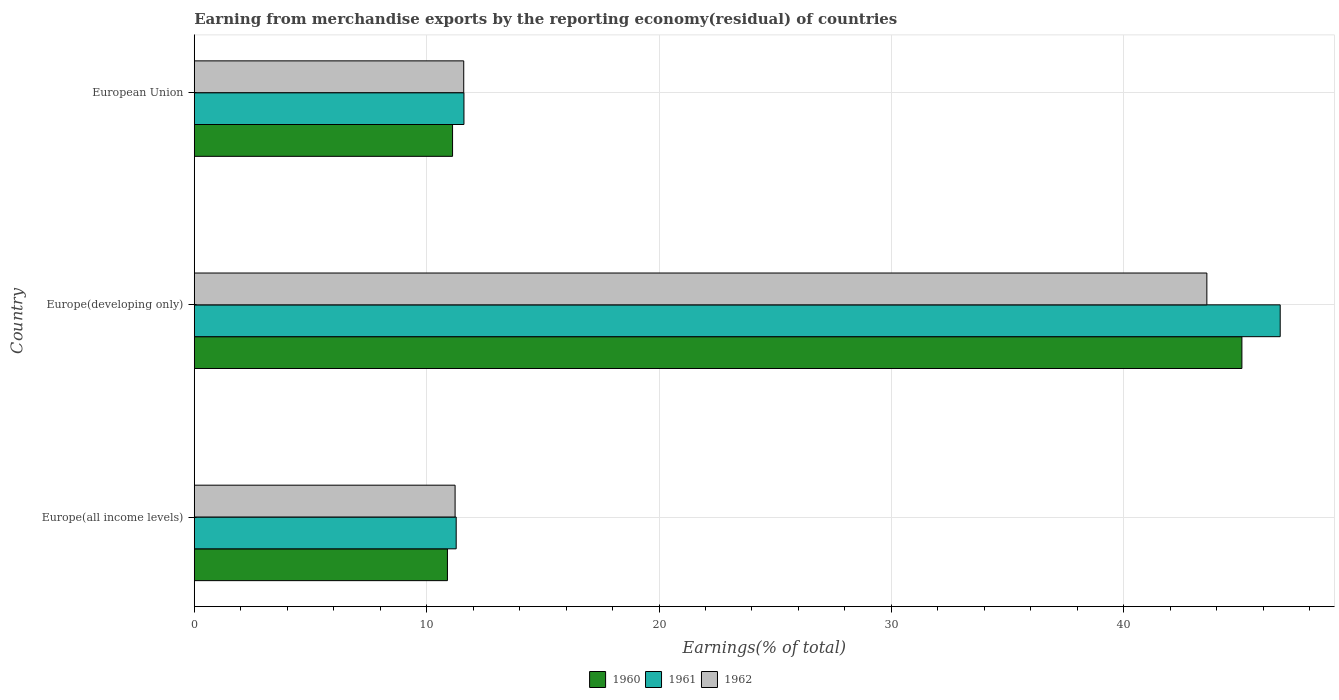Are the number of bars on each tick of the Y-axis equal?
Provide a succinct answer. Yes. How many bars are there on the 1st tick from the bottom?
Your response must be concise. 3. What is the label of the 3rd group of bars from the top?
Offer a terse response. Europe(all income levels). In how many cases, is the number of bars for a given country not equal to the number of legend labels?
Give a very brief answer. 0. What is the percentage of amount earned from merchandise exports in 1961 in European Union?
Ensure brevity in your answer.  11.61. Across all countries, what is the maximum percentage of amount earned from merchandise exports in 1962?
Your answer should be compact. 43.58. Across all countries, what is the minimum percentage of amount earned from merchandise exports in 1961?
Your answer should be very brief. 11.27. In which country was the percentage of amount earned from merchandise exports in 1962 maximum?
Keep it short and to the point. Europe(developing only). In which country was the percentage of amount earned from merchandise exports in 1962 minimum?
Keep it short and to the point. Europe(all income levels). What is the total percentage of amount earned from merchandise exports in 1962 in the graph?
Offer a very short reply. 66.4. What is the difference between the percentage of amount earned from merchandise exports in 1960 in Europe(developing only) and that in European Union?
Provide a short and direct response. 33.97. What is the difference between the percentage of amount earned from merchandise exports in 1961 in European Union and the percentage of amount earned from merchandise exports in 1962 in Europe(developing only)?
Provide a short and direct response. -31.97. What is the average percentage of amount earned from merchandise exports in 1962 per country?
Ensure brevity in your answer.  22.13. What is the difference between the percentage of amount earned from merchandise exports in 1960 and percentage of amount earned from merchandise exports in 1961 in Europe(all income levels)?
Offer a terse response. -0.38. In how many countries, is the percentage of amount earned from merchandise exports in 1962 greater than 10 %?
Your response must be concise. 3. What is the ratio of the percentage of amount earned from merchandise exports in 1962 in Europe(all income levels) to that in Europe(developing only)?
Your response must be concise. 0.26. Is the percentage of amount earned from merchandise exports in 1962 in Europe(all income levels) less than that in European Union?
Provide a succinct answer. Yes. What is the difference between the highest and the second highest percentage of amount earned from merchandise exports in 1962?
Provide a short and direct response. 31.98. What is the difference between the highest and the lowest percentage of amount earned from merchandise exports in 1962?
Offer a terse response. 32.35. How many bars are there?
Your answer should be very brief. 9. What is the difference between two consecutive major ticks on the X-axis?
Your answer should be compact. 10. Does the graph contain any zero values?
Provide a short and direct response. No. How many legend labels are there?
Ensure brevity in your answer.  3. What is the title of the graph?
Give a very brief answer. Earning from merchandise exports by the reporting economy(residual) of countries. What is the label or title of the X-axis?
Provide a short and direct response. Earnings(% of total). What is the label or title of the Y-axis?
Offer a terse response. Country. What is the Earnings(% of total) in 1960 in Europe(all income levels)?
Your answer should be compact. 10.9. What is the Earnings(% of total) in 1961 in Europe(all income levels)?
Offer a terse response. 11.27. What is the Earnings(% of total) of 1962 in Europe(all income levels)?
Your answer should be compact. 11.22. What is the Earnings(% of total) of 1960 in Europe(developing only)?
Make the answer very short. 45.08. What is the Earnings(% of total) in 1961 in Europe(developing only)?
Offer a terse response. 46.73. What is the Earnings(% of total) of 1962 in Europe(developing only)?
Ensure brevity in your answer.  43.58. What is the Earnings(% of total) in 1960 in European Union?
Your answer should be compact. 11.12. What is the Earnings(% of total) of 1961 in European Union?
Make the answer very short. 11.61. What is the Earnings(% of total) in 1962 in European Union?
Provide a succinct answer. 11.6. Across all countries, what is the maximum Earnings(% of total) of 1960?
Your answer should be very brief. 45.08. Across all countries, what is the maximum Earnings(% of total) of 1961?
Keep it short and to the point. 46.73. Across all countries, what is the maximum Earnings(% of total) in 1962?
Keep it short and to the point. 43.58. Across all countries, what is the minimum Earnings(% of total) of 1960?
Keep it short and to the point. 10.9. Across all countries, what is the minimum Earnings(% of total) of 1961?
Give a very brief answer. 11.27. Across all countries, what is the minimum Earnings(% of total) in 1962?
Offer a very short reply. 11.22. What is the total Earnings(% of total) in 1960 in the graph?
Your answer should be very brief. 67.1. What is the total Earnings(% of total) in 1961 in the graph?
Make the answer very short. 69.61. What is the total Earnings(% of total) of 1962 in the graph?
Ensure brevity in your answer.  66.4. What is the difference between the Earnings(% of total) of 1960 in Europe(all income levels) and that in Europe(developing only)?
Your response must be concise. -34.19. What is the difference between the Earnings(% of total) of 1961 in Europe(all income levels) and that in Europe(developing only)?
Give a very brief answer. -35.46. What is the difference between the Earnings(% of total) of 1962 in Europe(all income levels) and that in Europe(developing only)?
Ensure brevity in your answer.  -32.35. What is the difference between the Earnings(% of total) in 1960 in Europe(all income levels) and that in European Union?
Keep it short and to the point. -0.22. What is the difference between the Earnings(% of total) in 1961 in Europe(all income levels) and that in European Union?
Ensure brevity in your answer.  -0.33. What is the difference between the Earnings(% of total) in 1962 in Europe(all income levels) and that in European Union?
Ensure brevity in your answer.  -0.37. What is the difference between the Earnings(% of total) in 1960 in Europe(developing only) and that in European Union?
Make the answer very short. 33.97. What is the difference between the Earnings(% of total) of 1961 in Europe(developing only) and that in European Union?
Offer a terse response. 35.13. What is the difference between the Earnings(% of total) in 1962 in Europe(developing only) and that in European Union?
Keep it short and to the point. 31.98. What is the difference between the Earnings(% of total) of 1960 in Europe(all income levels) and the Earnings(% of total) of 1961 in Europe(developing only)?
Give a very brief answer. -35.84. What is the difference between the Earnings(% of total) of 1960 in Europe(all income levels) and the Earnings(% of total) of 1962 in Europe(developing only)?
Keep it short and to the point. -32.68. What is the difference between the Earnings(% of total) of 1961 in Europe(all income levels) and the Earnings(% of total) of 1962 in Europe(developing only)?
Offer a very short reply. -32.3. What is the difference between the Earnings(% of total) in 1960 in Europe(all income levels) and the Earnings(% of total) in 1961 in European Union?
Offer a terse response. -0.71. What is the difference between the Earnings(% of total) of 1960 in Europe(all income levels) and the Earnings(% of total) of 1962 in European Union?
Provide a short and direct response. -0.7. What is the difference between the Earnings(% of total) of 1961 in Europe(all income levels) and the Earnings(% of total) of 1962 in European Union?
Provide a short and direct response. -0.32. What is the difference between the Earnings(% of total) in 1960 in Europe(developing only) and the Earnings(% of total) in 1961 in European Union?
Ensure brevity in your answer.  33.48. What is the difference between the Earnings(% of total) of 1960 in Europe(developing only) and the Earnings(% of total) of 1962 in European Union?
Make the answer very short. 33.49. What is the difference between the Earnings(% of total) of 1961 in Europe(developing only) and the Earnings(% of total) of 1962 in European Union?
Provide a succinct answer. 35.14. What is the average Earnings(% of total) in 1960 per country?
Your response must be concise. 22.37. What is the average Earnings(% of total) in 1961 per country?
Provide a succinct answer. 23.2. What is the average Earnings(% of total) in 1962 per country?
Make the answer very short. 22.13. What is the difference between the Earnings(% of total) of 1960 and Earnings(% of total) of 1961 in Europe(all income levels)?
Offer a very short reply. -0.38. What is the difference between the Earnings(% of total) in 1960 and Earnings(% of total) in 1962 in Europe(all income levels)?
Make the answer very short. -0.33. What is the difference between the Earnings(% of total) of 1961 and Earnings(% of total) of 1962 in Europe(all income levels)?
Make the answer very short. 0.05. What is the difference between the Earnings(% of total) of 1960 and Earnings(% of total) of 1961 in Europe(developing only)?
Offer a very short reply. -1.65. What is the difference between the Earnings(% of total) in 1960 and Earnings(% of total) in 1962 in Europe(developing only)?
Offer a terse response. 1.51. What is the difference between the Earnings(% of total) of 1961 and Earnings(% of total) of 1962 in Europe(developing only)?
Your response must be concise. 3.16. What is the difference between the Earnings(% of total) in 1960 and Earnings(% of total) in 1961 in European Union?
Provide a succinct answer. -0.49. What is the difference between the Earnings(% of total) of 1960 and Earnings(% of total) of 1962 in European Union?
Make the answer very short. -0.48. What is the difference between the Earnings(% of total) in 1961 and Earnings(% of total) in 1962 in European Union?
Offer a terse response. 0.01. What is the ratio of the Earnings(% of total) in 1960 in Europe(all income levels) to that in Europe(developing only)?
Provide a succinct answer. 0.24. What is the ratio of the Earnings(% of total) in 1961 in Europe(all income levels) to that in Europe(developing only)?
Give a very brief answer. 0.24. What is the ratio of the Earnings(% of total) of 1962 in Europe(all income levels) to that in Europe(developing only)?
Offer a terse response. 0.26. What is the ratio of the Earnings(% of total) of 1960 in Europe(all income levels) to that in European Union?
Provide a succinct answer. 0.98. What is the ratio of the Earnings(% of total) of 1961 in Europe(all income levels) to that in European Union?
Keep it short and to the point. 0.97. What is the ratio of the Earnings(% of total) in 1962 in Europe(all income levels) to that in European Union?
Your response must be concise. 0.97. What is the ratio of the Earnings(% of total) in 1960 in Europe(developing only) to that in European Union?
Your answer should be compact. 4.06. What is the ratio of the Earnings(% of total) in 1961 in Europe(developing only) to that in European Union?
Provide a short and direct response. 4.03. What is the ratio of the Earnings(% of total) of 1962 in Europe(developing only) to that in European Union?
Keep it short and to the point. 3.76. What is the difference between the highest and the second highest Earnings(% of total) in 1960?
Your response must be concise. 33.97. What is the difference between the highest and the second highest Earnings(% of total) in 1961?
Ensure brevity in your answer.  35.13. What is the difference between the highest and the second highest Earnings(% of total) of 1962?
Ensure brevity in your answer.  31.98. What is the difference between the highest and the lowest Earnings(% of total) in 1960?
Offer a terse response. 34.19. What is the difference between the highest and the lowest Earnings(% of total) in 1961?
Offer a very short reply. 35.46. What is the difference between the highest and the lowest Earnings(% of total) of 1962?
Give a very brief answer. 32.35. 